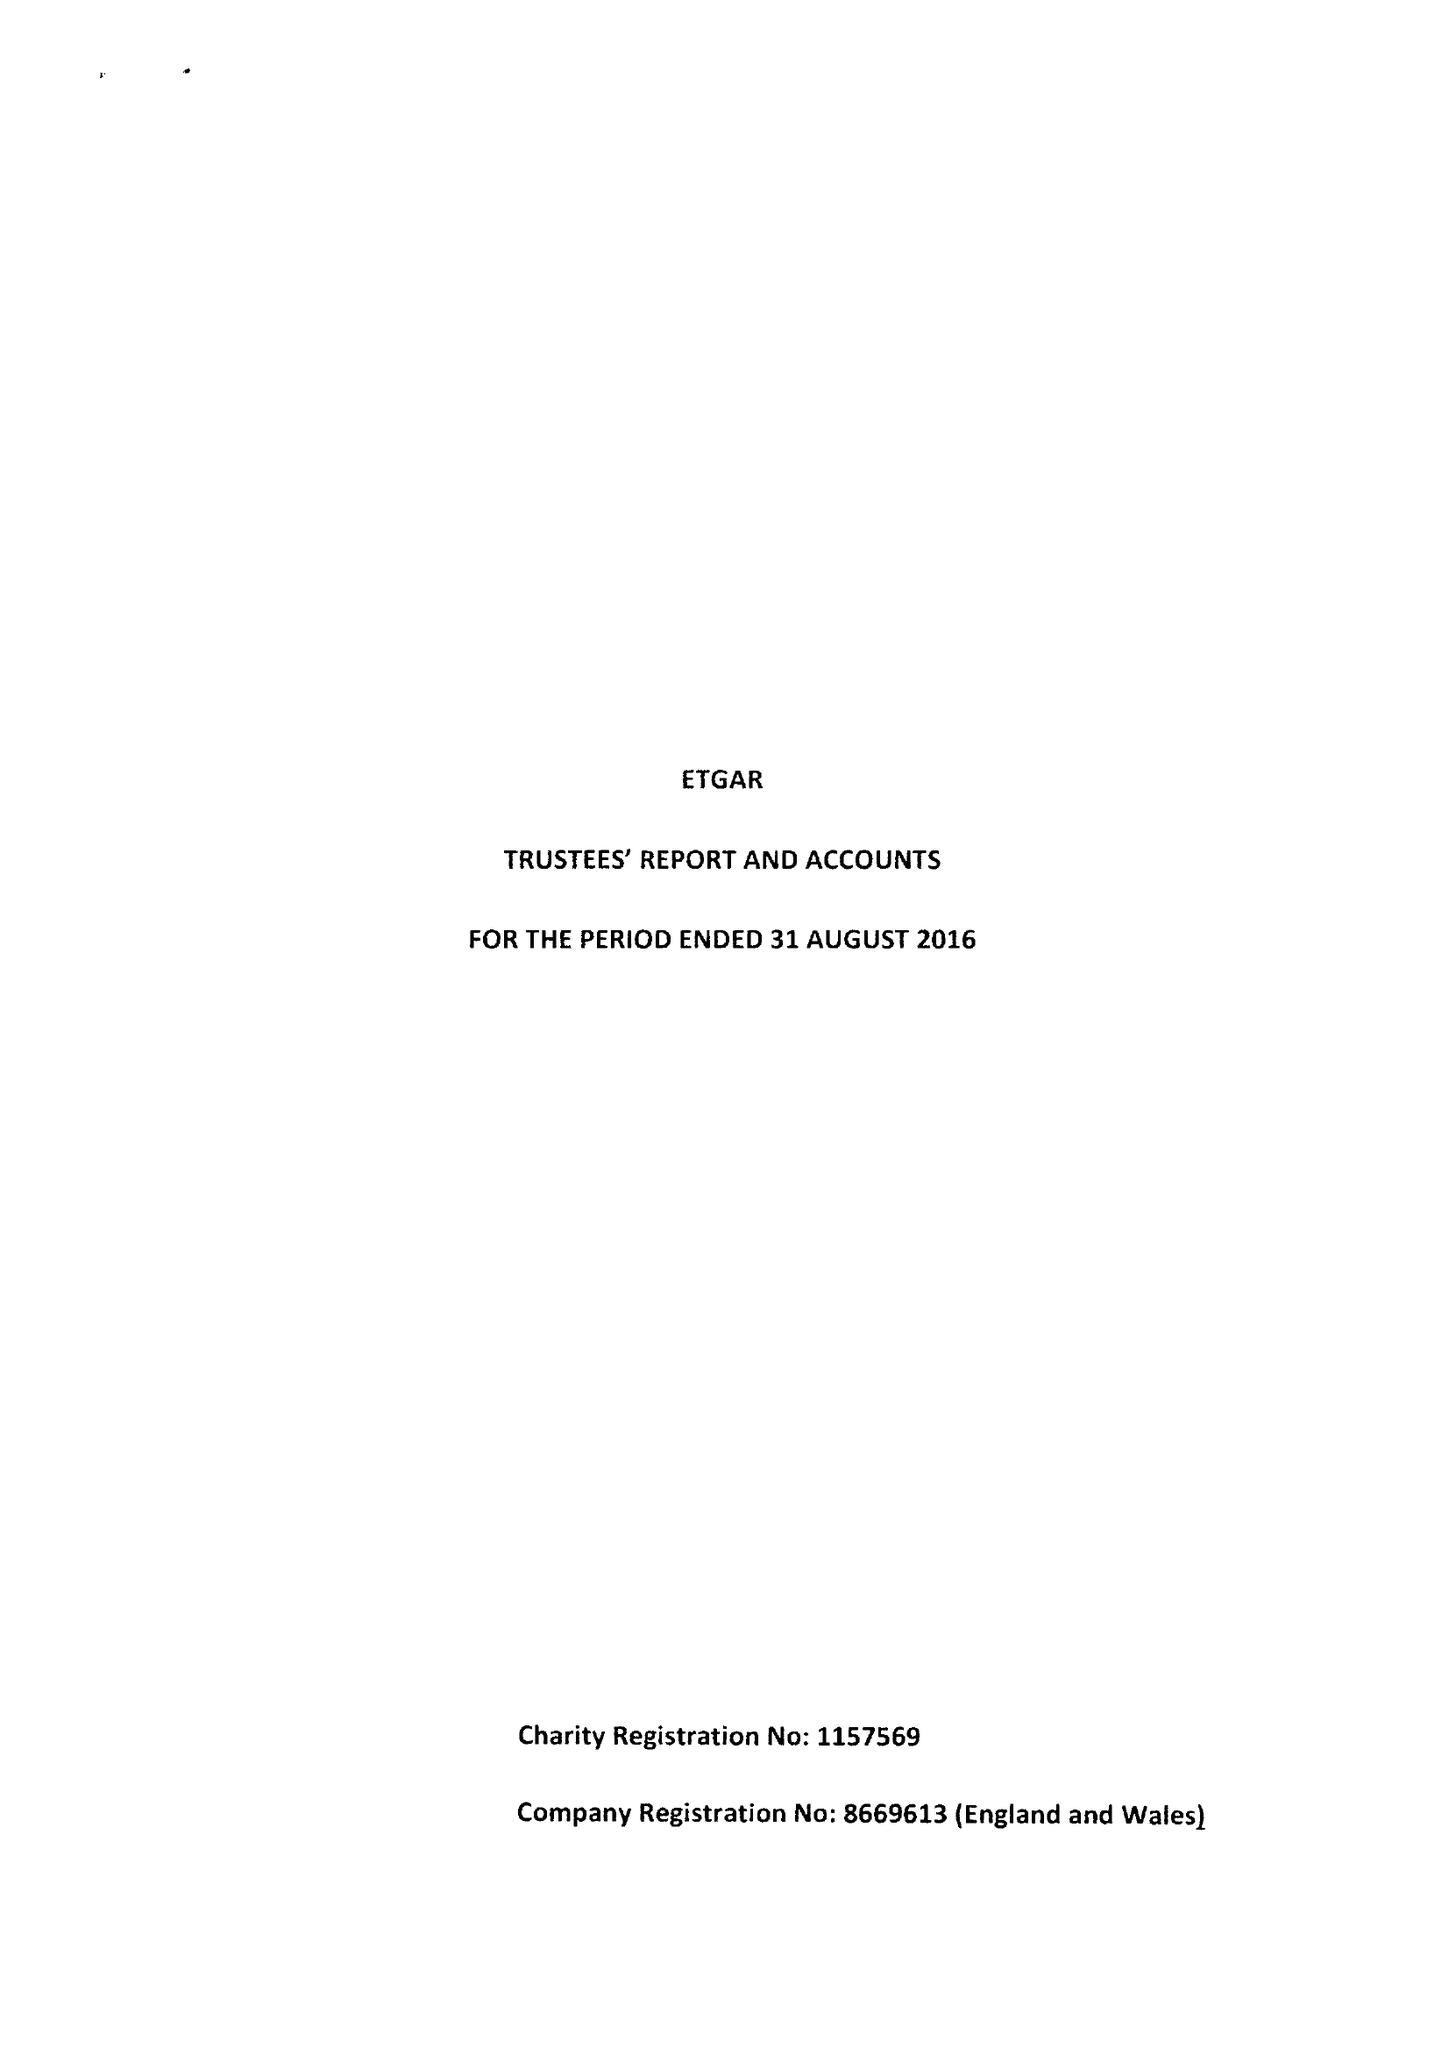What is the value for the spending_annually_in_british_pounds?
Answer the question using a single word or phrase. 104800.00 